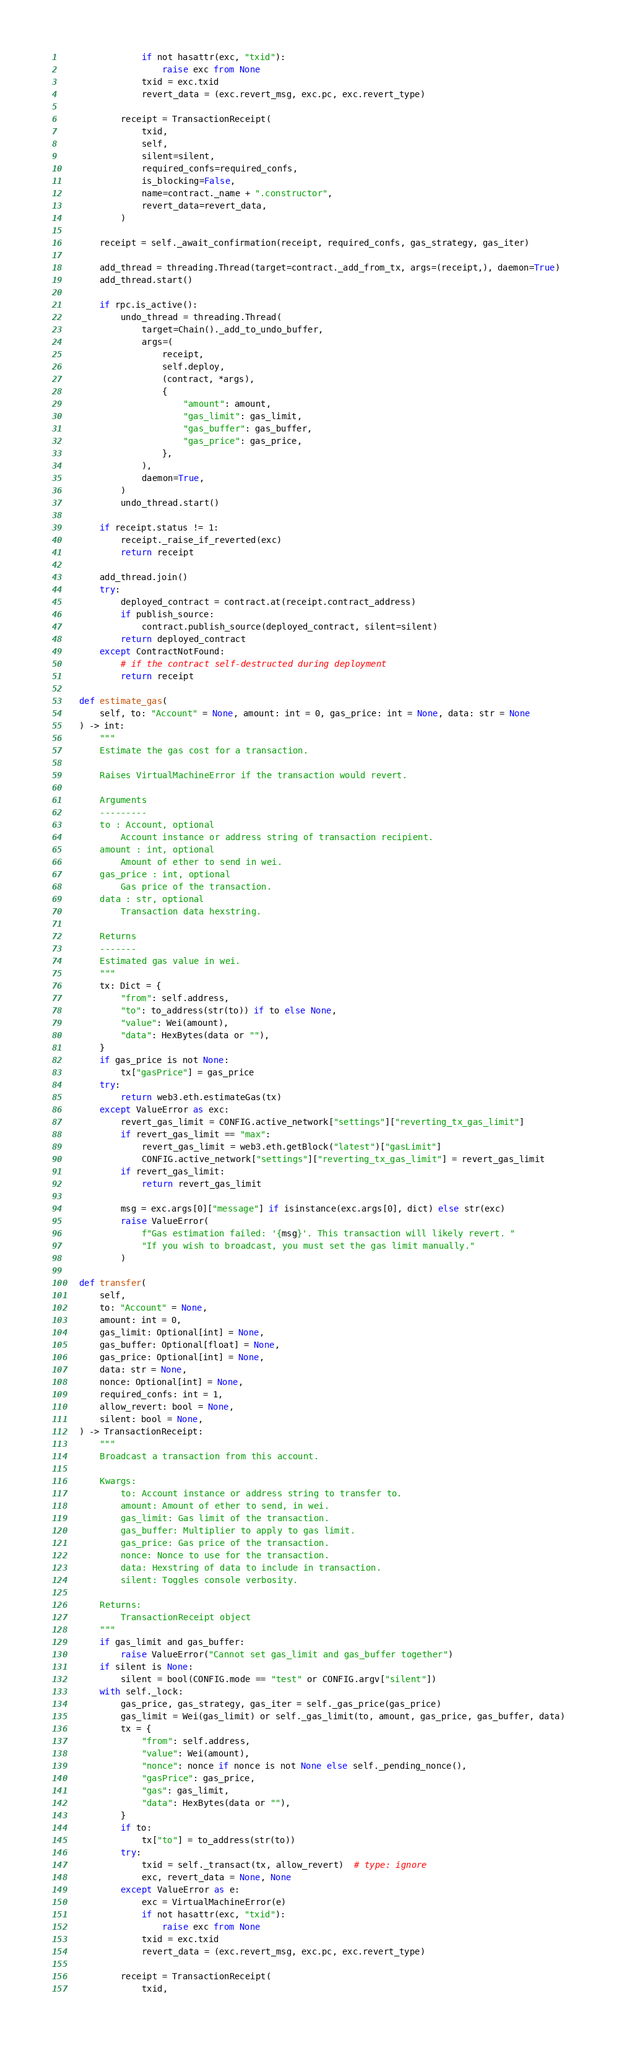<code> <loc_0><loc_0><loc_500><loc_500><_Python_>                if not hasattr(exc, "txid"):
                    raise exc from None
                txid = exc.txid
                revert_data = (exc.revert_msg, exc.pc, exc.revert_type)

            receipt = TransactionReceipt(
                txid,
                self,
                silent=silent,
                required_confs=required_confs,
                is_blocking=False,
                name=contract._name + ".constructor",
                revert_data=revert_data,
            )

        receipt = self._await_confirmation(receipt, required_confs, gas_strategy, gas_iter)

        add_thread = threading.Thread(target=contract._add_from_tx, args=(receipt,), daemon=True)
        add_thread.start()

        if rpc.is_active():
            undo_thread = threading.Thread(
                target=Chain()._add_to_undo_buffer,
                args=(
                    receipt,
                    self.deploy,
                    (contract, *args),
                    {
                        "amount": amount,
                        "gas_limit": gas_limit,
                        "gas_buffer": gas_buffer,
                        "gas_price": gas_price,
                    },
                ),
                daemon=True,
            )
            undo_thread.start()

        if receipt.status != 1:
            receipt._raise_if_reverted(exc)
            return receipt

        add_thread.join()
        try:
            deployed_contract = contract.at(receipt.contract_address)
            if publish_source:
                contract.publish_source(deployed_contract, silent=silent)
            return deployed_contract
        except ContractNotFound:
            # if the contract self-destructed during deployment
            return receipt

    def estimate_gas(
        self, to: "Account" = None, amount: int = 0, gas_price: int = None, data: str = None
    ) -> int:
        """
        Estimate the gas cost for a transaction.

        Raises VirtualMachineError if the transaction would revert.

        Arguments
        ---------
        to : Account, optional
            Account instance or address string of transaction recipient.
        amount : int, optional
            Amount of ether to send in wei.
        gas_price : int, optional
            Gas price of the transaction.
        data : str, optional
            Transaction data hexstring.

        Returns
        -------
        Estimated gas value in wei.
        """
        tx: Dict = {
            "from": self.address,
            "to": to_address(str(to)) if to else None,
            "value": Wei(amount),
            "data": HexBytes(data or ""),
        }
        if gas_price is not None:
            tx["gasPrice"] = gas_price
        try:
            return web3.eth.estimateGas(tx)
        except ValueError as exc:
            revert_gas_limit = CONFIG.active_network["settings"]["reverting_tx_gas_limit"]
            if revert_gas_limit == "max":
                revert_gas_limit = web3.eth.getBlock("latest")["gasLimit"]
                CONFIG.active_network["settings"]["reverting_tx_gas_limit"] = revert_gas_limit
            if revert_gas_limit:
                return revert_gas_limit

            msg = exc.args[0]["message"] if isinstance(exc.args[0], dict) else str(exc)
            raise ValueError(
                f"Gas estimation failed: '{msg}'. This transaction will likely revert. "
                "If you wish to broadcast, you must set the gas limit manually."
            )

    def transfer(
        self,
        to: "Account" = None,
        amount: int = 0,
        gas_limit: Optional[int] = None,
        gas_buffer: Optional[float] = None,
        gas_price: Optional[int] = None,
        data: str = None,
        nonce: Optional[int] = None,
        required_confs: int = 1,
        allow_revert: bool = None,
        silent: bool = None,
    ) -> TransactionReceipt:
        """
        Broadcast a transaction from this account.

        Kwargs:
            to: Account instance or address string to transfer to.
            amount: Amount of ether to send, in wei.
            gas_limit: Gas limit of the transaction.
            gas_buffer: Multiplier to apply to gas limit.
            gas_price: Gas price of the transaction.
            nonce: Nonce to use for the transaction.
            data: Hexstring of data to include in transaction.
            silent: Toggles console verbosity.

        Returns:
            TransactionReceipt object
        """
        if gas_limit and gas_buffer:
            raise ValueError("Cannot set gas_limit and gas_buffer together")
        if silent is None:
            silent = bool(CONFIG.mode == "test" or CONFIG.argv["silent"])
        with self._lock:
            gas_price, gas_strategy, gas_iter = self._gas_price(gas_price)
            gas_limit = Wei(gas_limit) or self._gas_limit(to, amount, gas_price, gas_buffer, data)
            tx = {
                "from": self.address,
                "value": Wei(amount),
                "nonce": nonce if nonce is not None else self._pending_nonce(),
                "gasPrice": gas_price,
                "gas": gas_limit,
                "data": HexBytes(data or ""),
            }
            if to:
                tx["to"] = to_address(str(to))
            try:
                txid = self._transact(tx, allow_revert)  # type: ignore
                exc, revert_data = None, None
            except ValueError as e:
                exc = VirtualMachineError(e)
                if not hasattr(exc, "txid"):
                    raise exc from None
                txid = exc.txid
                revert_data = (exc.revert_msg, exc.pc, exc.revert_type)

            receipt = TransactionReceipt(
                txid,</code> 